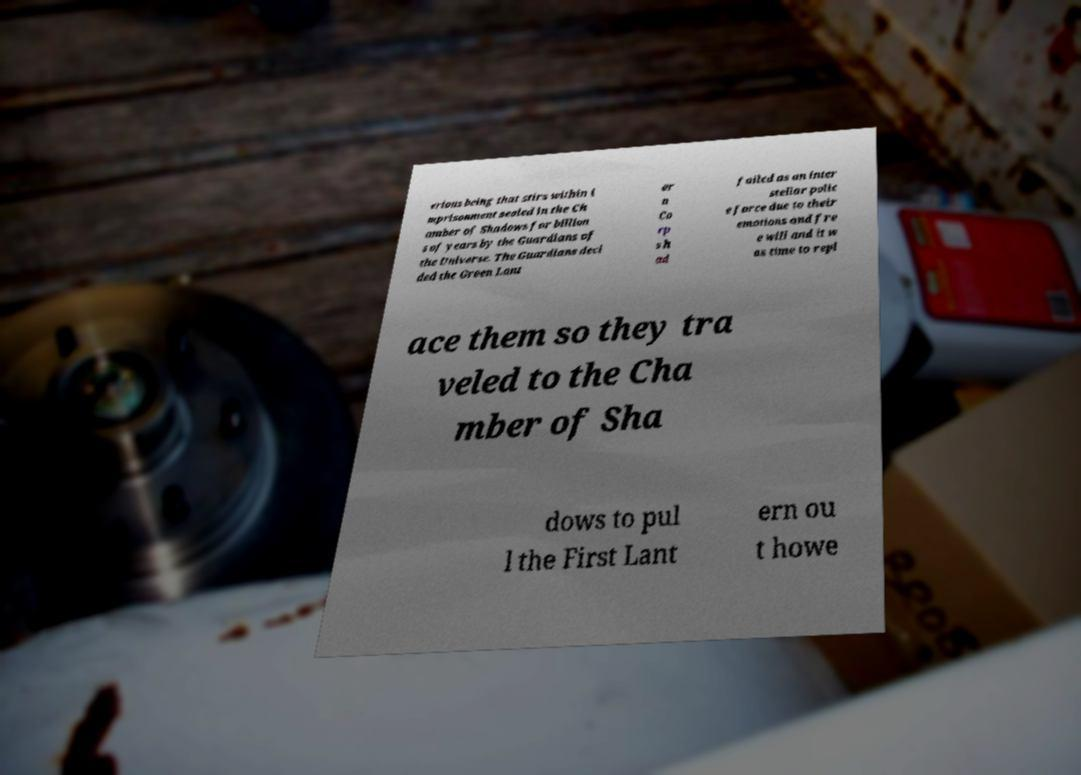For documentation purposes, I need the text within this image transcribed. Could you provide that? erious being that stirs within i mprisonment sealed in the Ch amber of Shadows for billion s of years by the Guardians of the Universe. The Guardians deci ded the Green Lant er n Co rp s h ad failed as an inter stellar polic e force due to their emotions and fre e will and it w as time to repl ace them so they tra veled to the Cha mber of Sha dows to pul l the First Lant ern ou t howe 